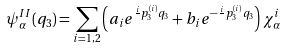Convert formula to latex. <formula><loc_0><loc_0><loc_500><loc_500>\psi _ { \alpha } ^ { I I } ( q _ { 3 } ) = \sum _ { i = 1 , 2 } \left ( a _ { i } e ^ { \frac { i } { } p _ { 3 } ^ { ( i ) } q _ { 3 } } + b _ { i } e ^ { - \frac { i } { } p _ { 3 } ^ { ( i ) } q _ { 3 } } \right ) \chi _ { \alpha } ^ { i }</formula> 